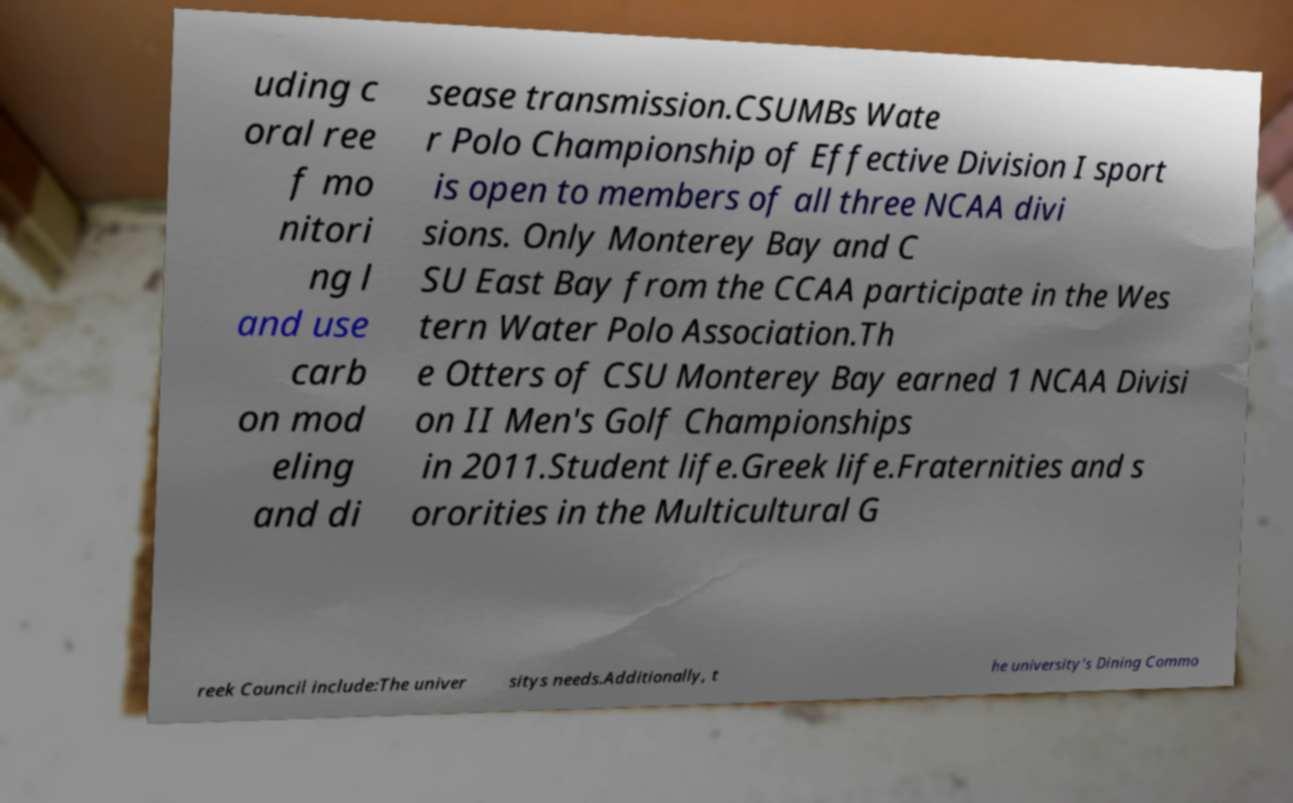I need the written content from this picture converted into text. Can you do that? uding c oral ree f mo nitori ng l and use carb on mod eling and di sease transmission.CSUMBs Wate r Polo Championship of Effective Division I sport is open to members of all three NCAA divi sions. Only Monterey Bay and C SU East Bay from the CCAA participate in the Wes tern Water Polo Association.Th e Otters of CSU Monterey Bay earned 1 NCAA Divisi on II Men's Golf Championships in 2011.Student life.Greek life.Fraternities and s ororities in the Multicultural G reek Council include:The univer sitys needs.Additionally, t he university's Dining Commo 